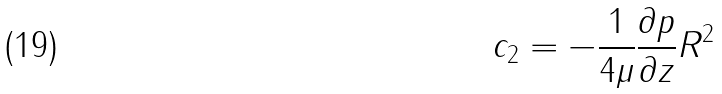Convert formula to latex. <formula><loc_0><loc_0><loc_500><loc_500>c _ { 2 } = - \frac { 1 } { 4 \mu } \frac { \partial p } { \partial z } R ^ { 2 }</formula> 